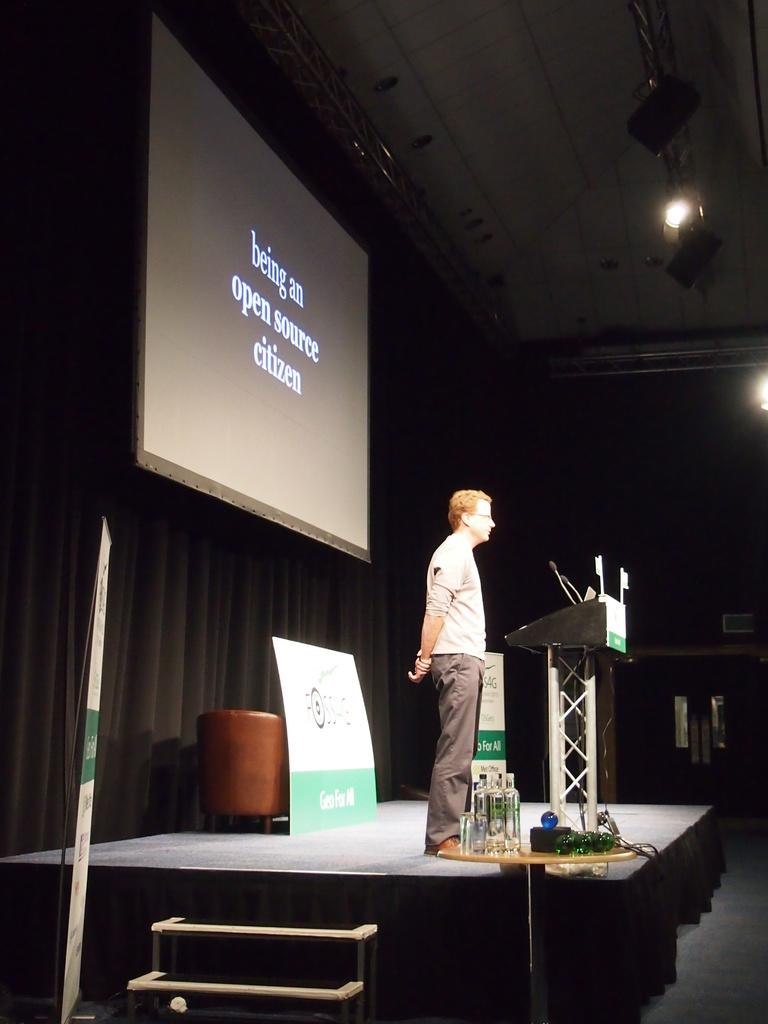Who is the main subject in the image? There is a man in the image. What is the man doing in the image? The man is standing in front of a podium. What object is present for the man to speak into? There is a microphone in the image. What is the purpose of the projector screen in the image? The projector screen is likely used for displaying visual aids during the man's presentation. What type of pet can be seen playing with the man in the image? There is no pet present in the image; the man is standing in front of a podium with a microphone and a projector screen. 